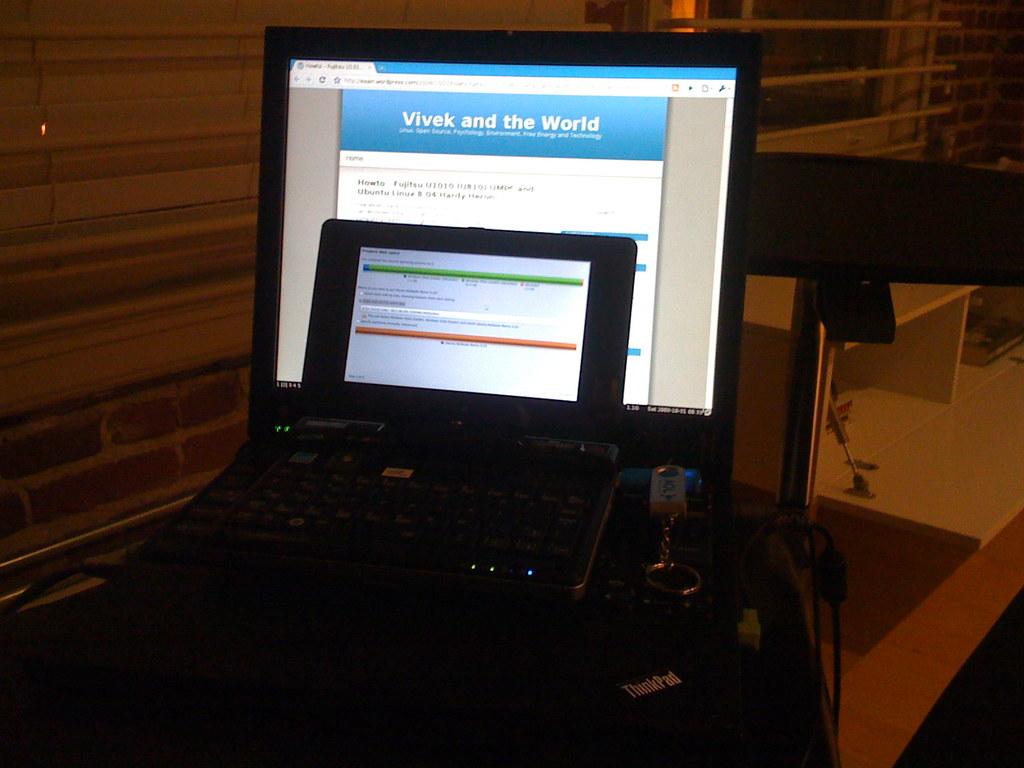What is the title of the website on the screen?
Keep it short and to the point. Vivek and the world. What is the mouse pad?
Provide a short and direct response. Thinkpad. 